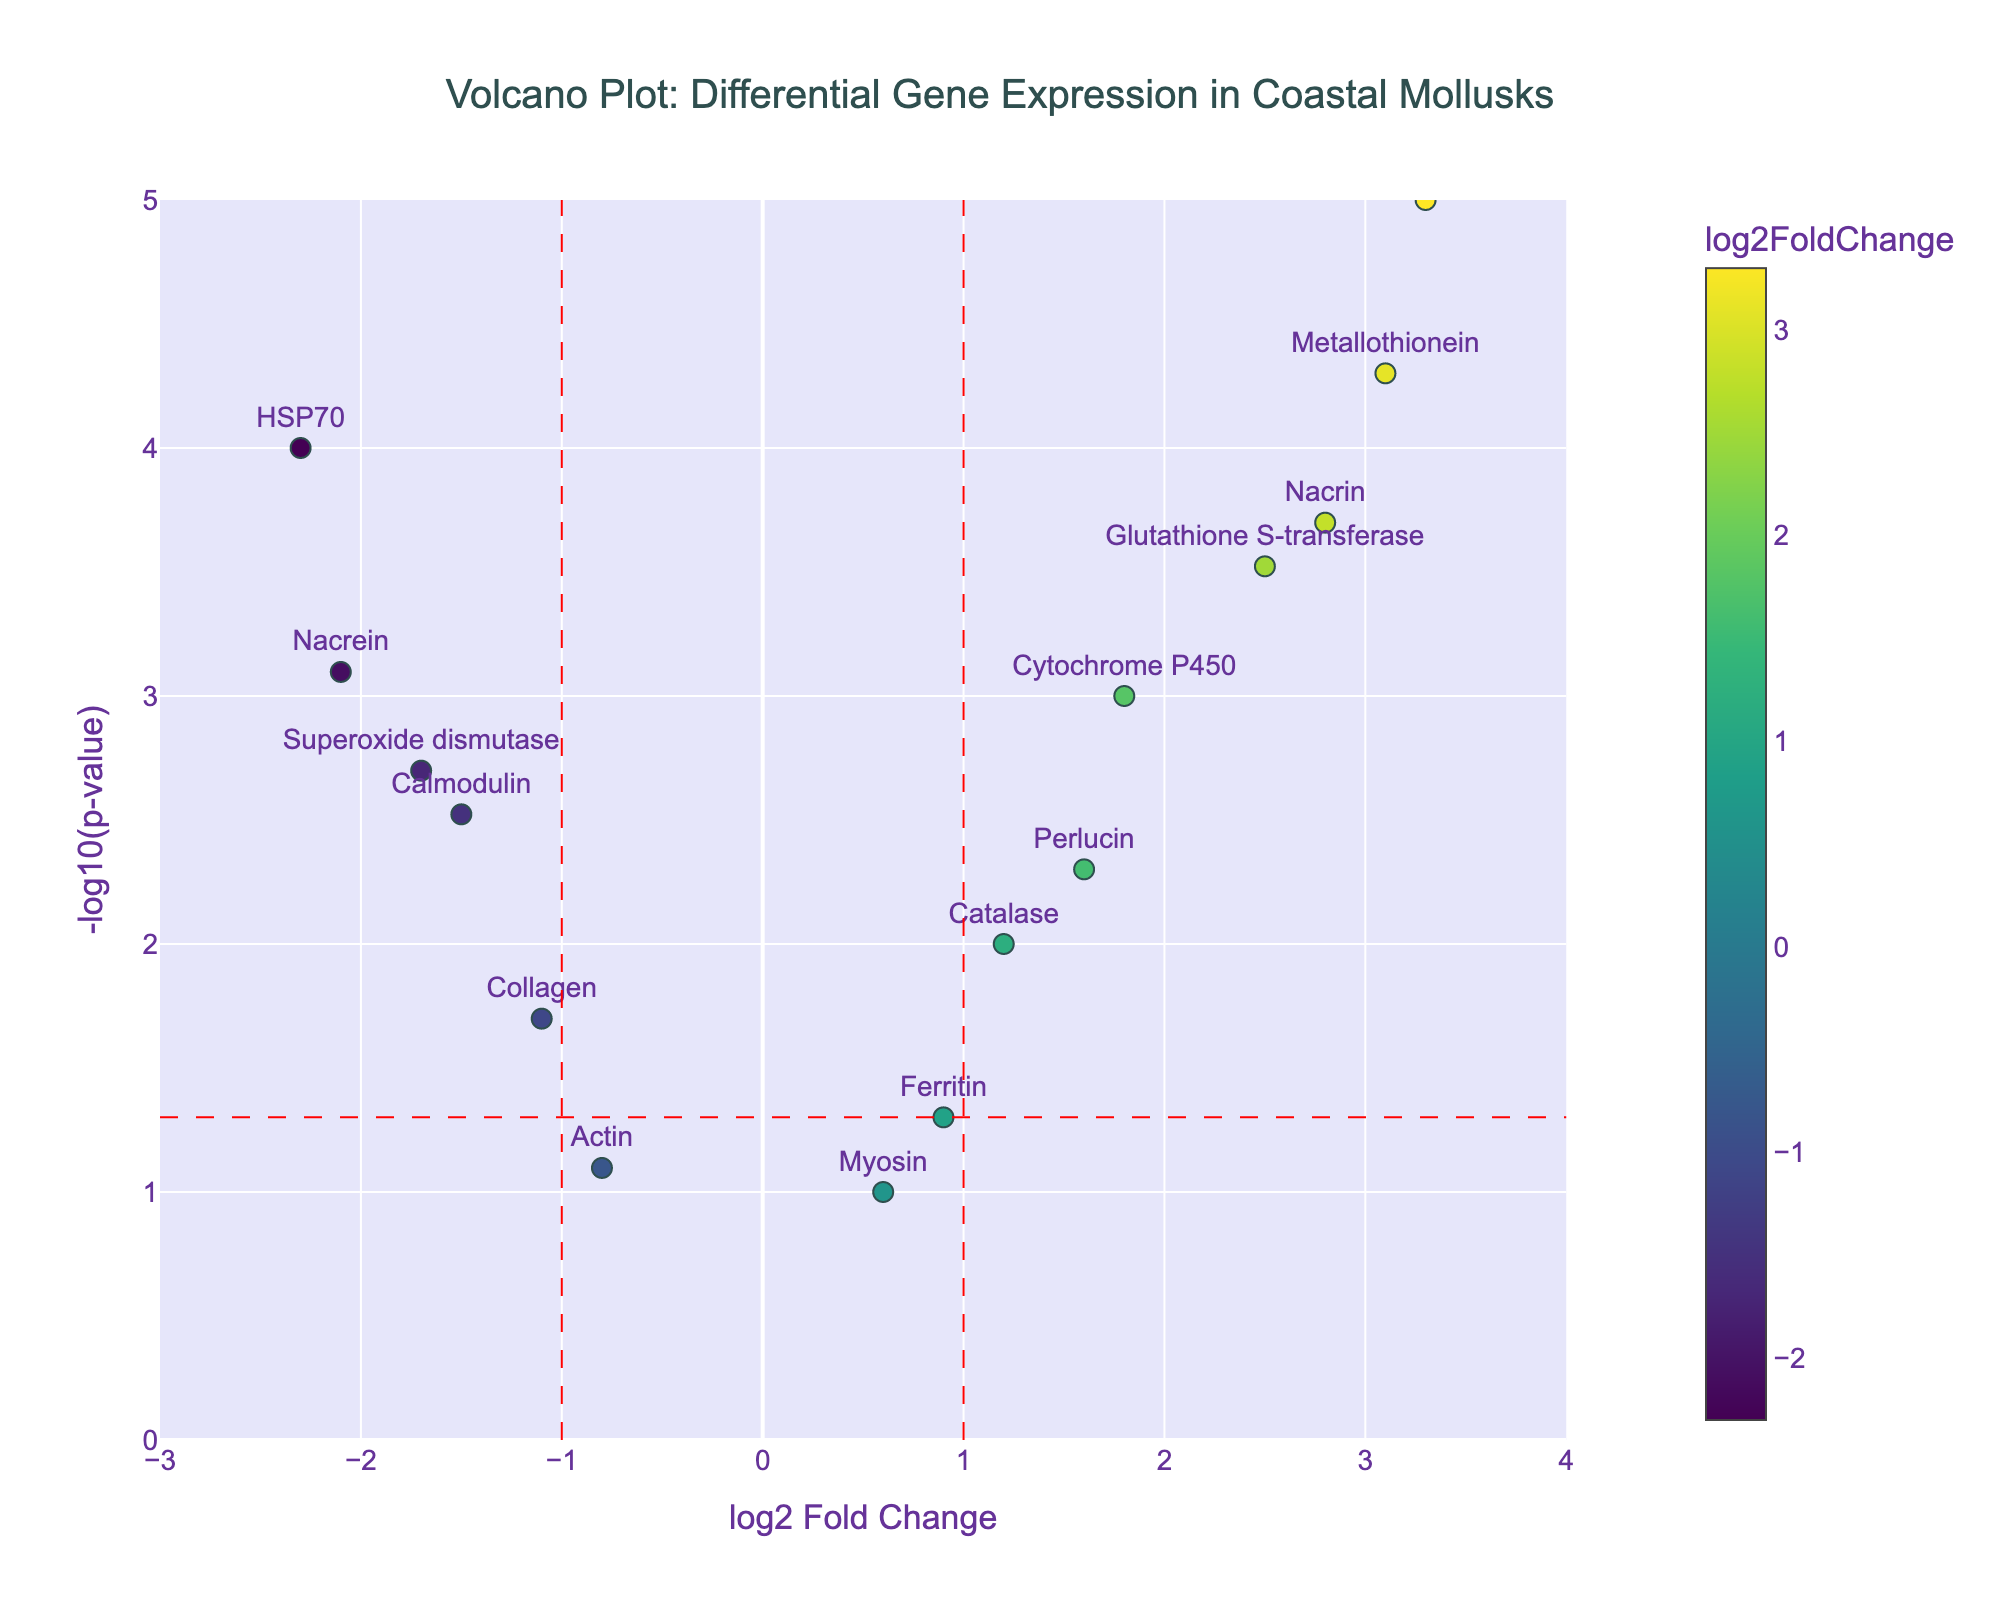What is the title of the volcano plot? The title is located at the top center of the plot.
Answer: "Volcano Plot: Differential Gene Expression in Coastal Mollusks" Which gene has the highest log2 Fold Change? By looking at the x-axis, the gene with the highest log2 Fold Change is the one furthest to the right.
Answer: Shell matrix protein Which gene has the lowest p-value? The lowest p-value corresponds to the highest -log10(p-value) on the y-axis.
Answer: Shell matrix protein How many genes have a log2 Fold Change greater than 1? Count the number of data points to the right of the vertical dashed red line at x=1.
Answer: 5 What is the log2 Fold Change of the gene "HSP70"? Find the gene "HSP70" in the figure and read its x-axis value.
Answer: -2.3 How many genes lie above the -log10(p-value) threshold of 1.3? Determine which points are above the horizontal dashed red line at y=1.3.
Answer: 10 Which gene has the highest -log10(p-value) and a negative log2 Fold Change? Look for the highest point on the plot with a negative x-axis value.
Answer: HSP70 Compare Metallothionein and Nacrins log2 Fold Change. Which is higher? Compare the x-axis positions of Metallothionein and Nacrin.
Answer: Metallothionein Are there more genes with positive or negative log2 Fold Changes? Count the genes on the right side of x=0 for positive changes and on the left for negative changes.
Answer: More positive What is the log2 Fold Change range on the x-axis? Read the values on the x-axis from the lowest to the highest.
Answer: -3 to 4 